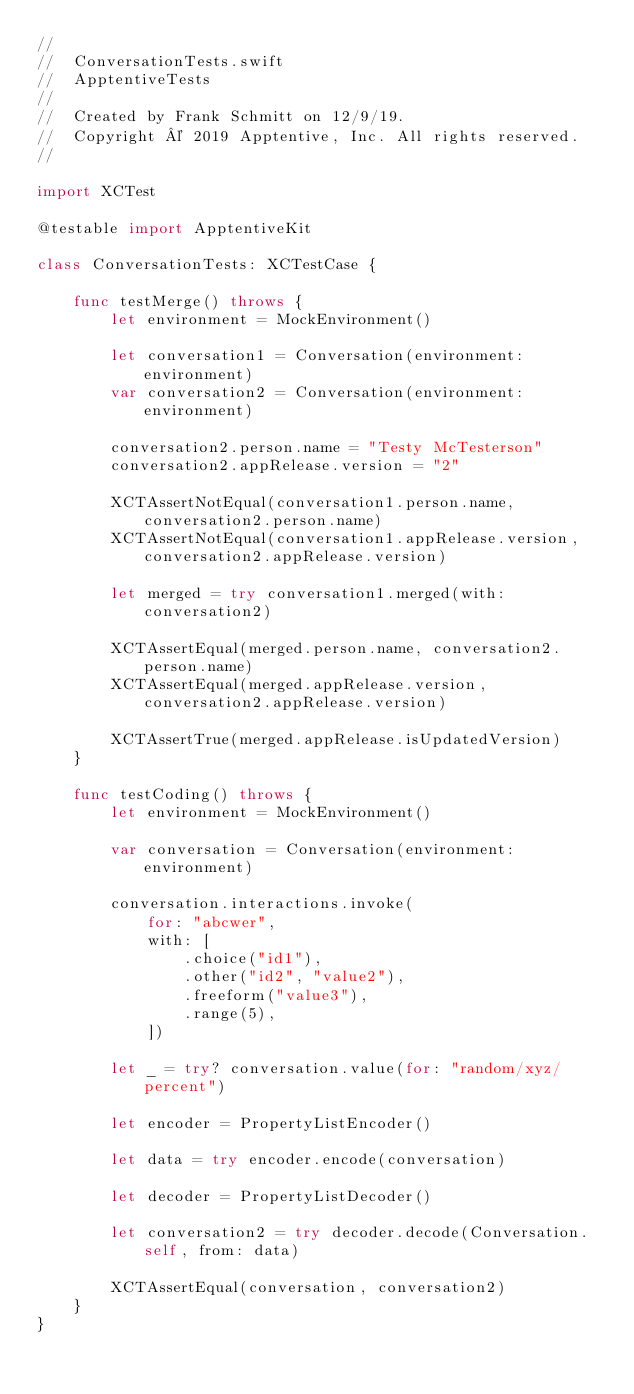<code> <loc_0><loc_0><loc_500><loc_500><_Swift_>//
//  ConversationTests.swift
//  ApptentiveTests
//
//  Created by Frank Schmitt on 12/9/19.
//  Copyright © 2019 Apptentive, Inc. All rights reserved.
//

import XCTest

@testable import ApptentiveKit

class ConversationTests: XCTestCase {

    func testMerge() throws {
        let environment = MockEnvironment()

        let conversation1 = Conversation(environment: environment)
        var conversation2 = Conversation(environment: environment)

        conversation2.person.name = "Testy McTesterson"
        conversation2.appRelease.version = "2"

        XCTAssertNotEqual(conversation1.person.name, conversation2.person.name)
        XCTAssertNotEqual(conversation1.appRelease.version, conversation2.appRelease.version)

        let merged = try conversation1.merged(with: conversation2)

        XCTAssertEqual(merged.person.name, conversation2.person.name)
        XCTAssertEqual(merged.appRelease.version, conversation2.appRelease.version)

        XCTAssertTrue(merged.appRelease.isUpdatedVersion)
    }

    func testCoding() throws {
        let environment = MockEnvironment()

        var conversation = Conversation(environment: environment)

        conversation.interactions.invoke(
            for: "abcwer",
            with: [
                .choice("id1"),
                .other("id2", "value2"),
                .freeform("value3"),
                .range(5),
            ])

        let _ = try? conversation.value(for: "random/xyz/percent")

        let encoder = PropertyListEncoder()

        let data = try encoder.encode(conversation)

        let decoder = PropertyListDecoder()

        let conversation2 = try decoder.decode(Conversation.self, from: data)

        XCTAssertEqual(conversation, conversation2)
    }
}
</code> 